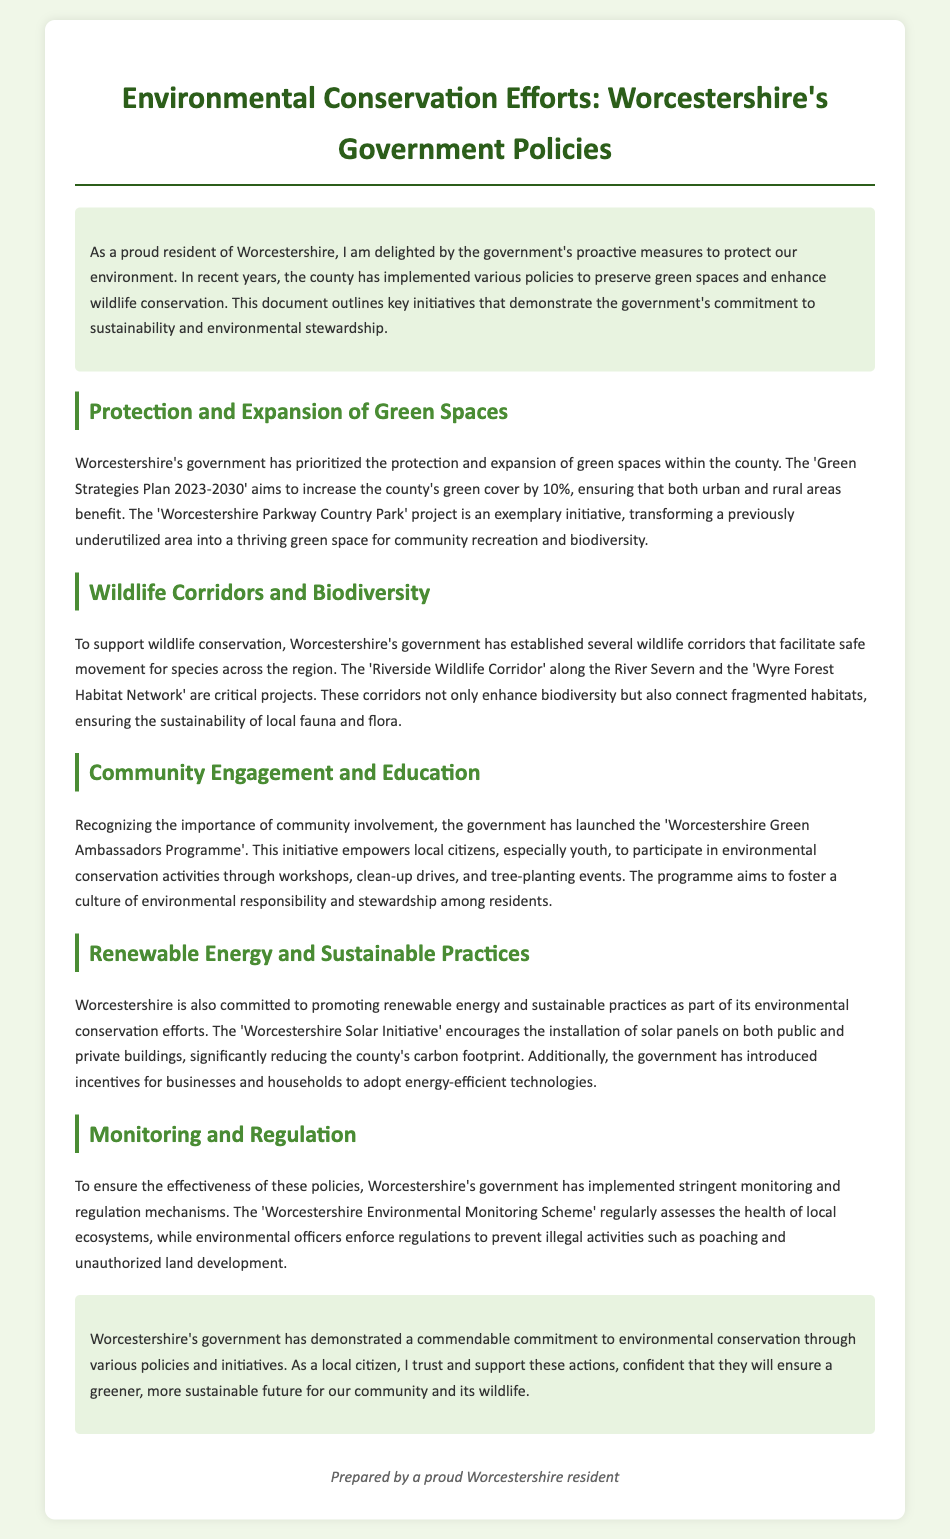What is the title of the government's plan for green spaces? The government plan aims to increase the county's green cover and is titled 'Green Strategies Plan 2023-2030'.
Answer: Green Strategies Plan 2023-2030 What is the aim of the 'Green Strategies Plan'? The plan aims to increase the county's green cover by 10%.
Answer: 10% What project is mentioned as transforming an underutilized area into a green space? The document describes the 'Worcestershire Parkway Country Park' project as an exemplary initiative for community recreation.
Answer: Worcestershire Parkway Country Park What wildlife corridor is mentioned along the River Severn? The 'Riverside Wildlife Corridor' facilitates safe movement for species across the region.
Answer: Riverside Wildlife Corridor What program empowers local citizens to engage in environmental activities? The 'Worcestershire Green Ambassadors Programme' is designed to involve citizens in conservation activities.
Answer: Worcestershire Green Ambassadors Programme What is one initiative promoting renewable energy in Worcestershire? The document states that the 'Worcestershire Solar Initiative' encourages solar panel installations.
Answer: Worcestershire Solar Initiative What mechanism does Worcestershire's government use for monitoring ecosystems? The 'Worcestershire Environmental Monitoring Scheme' regularly assesses the health of local ecosystems.
Answer: Worcestershire Environmental Monitoring Scheme Why is community involvement important in Worcestershire's environmental policies? Community involvement fosters a culture of environmental responsibility and stewardship among residents.
Answer: Environmental responsibility and stewardship What is the main focus of the government regarding wildlife? The government focuses on establishing wildlife corridors to enhance biodiversity and ensure sustainability.
Answer: Wildlife corridors 